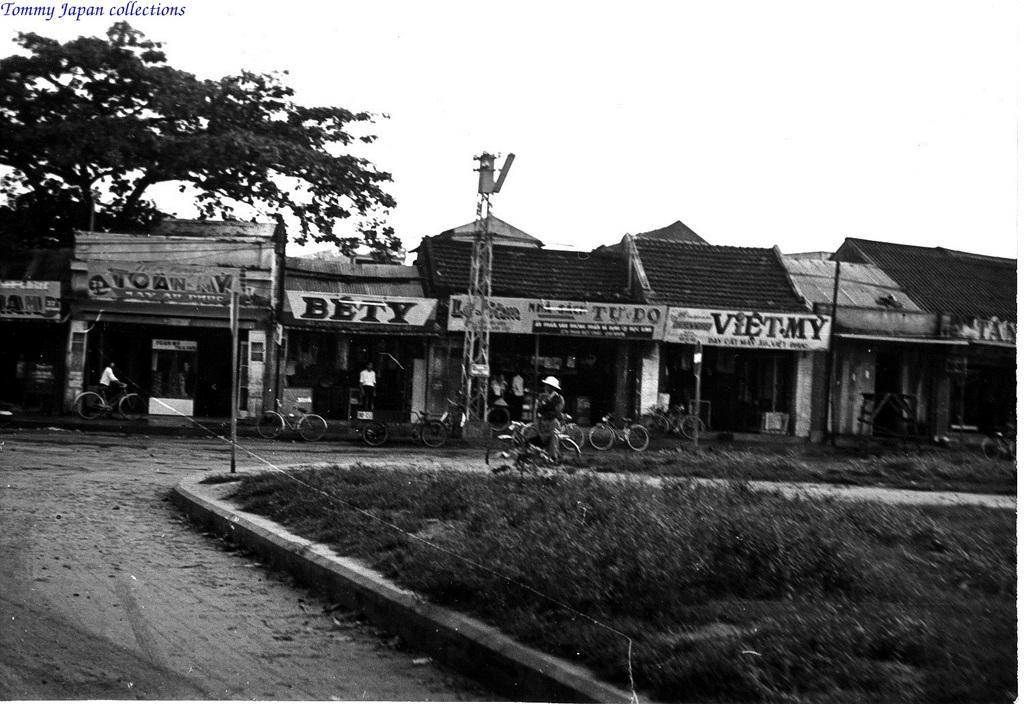In one or two sentences, can you explain what this image depicts? At the bottom of the image there is grass. In the middle of the image few people are riding bicycles. Behind them there are some bicycles and buildings and poles and sign boards. At the top of the image there is sky and there are some trees. 